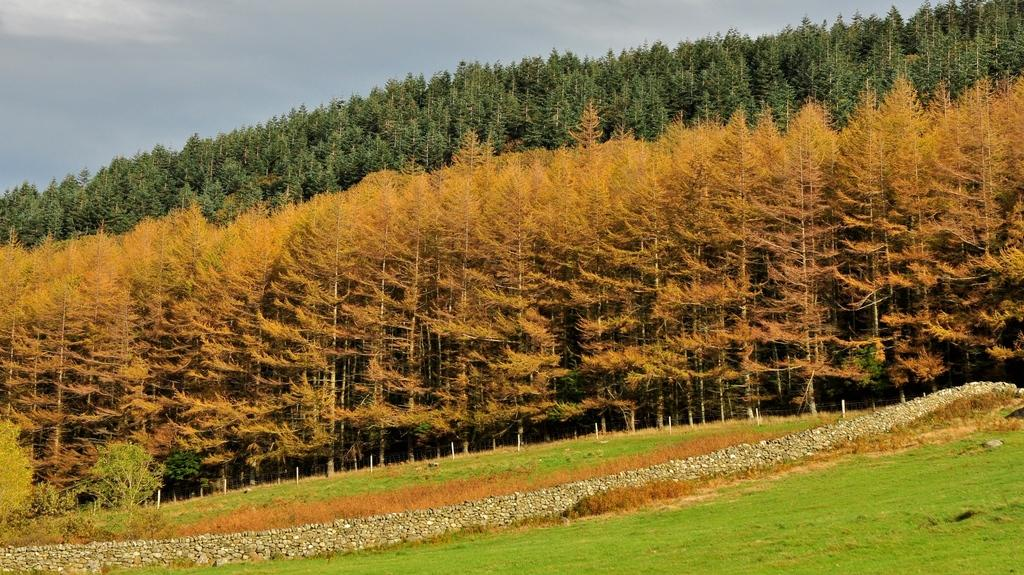What type of vegetation is present in the image? There are many trees in the image. What type of ground cover is visible in the image? There is grass visible in the image. What type of geological formation can be seen in the image? There are rocks in the image. How does the rat act in the image? There is no rat present in the image. Who is the visitor in the image? There is no visitor present in the image. 